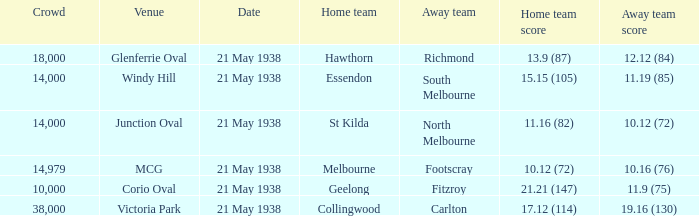Which Home team has a Venue of mcg? Melbourne. 